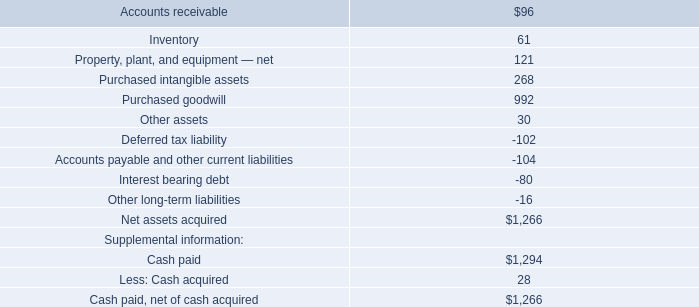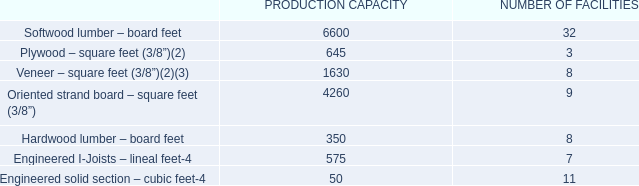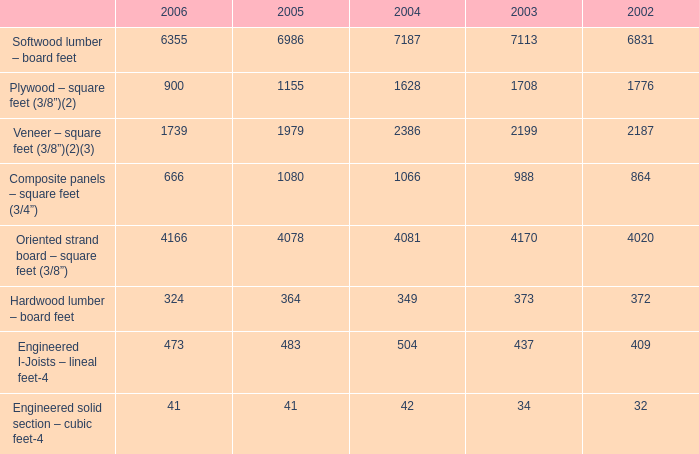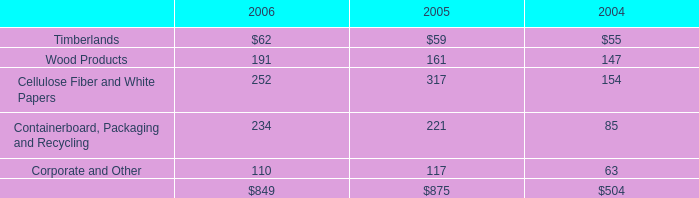Which element occupies the greatest proportion in total amount 2006? 
Answer: Softwood lumber – board feet. 